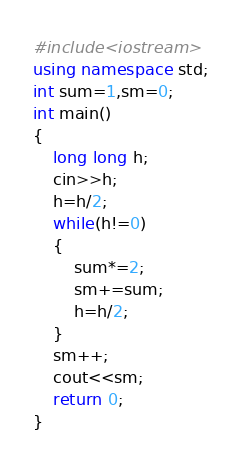<code> <loc_0><loc_0><loc_500><loc_500><_C++_>#include<iostream>
using namespace std;
int sum=1,sm=0;
int main()
{
	long long h;
	cin>>h;
	h=h/2;
	while(h!=0)
	{
		sum*=2;
		sm+=sum;
		h=h/2;	
	}
	sm++;
	cout<<sm;
	return 0;
}</code> 